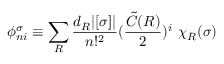Convert formula to latex. <formula><loc_0><loc_0><loc_500><loc_500>\phi _ { n i } ^ { \sigma } \equiv \sum _ { R } \frac { d _ { R } | [ \sigma ] | } { n ! ^ { 2 } } ( \frac { { \tilde { C } } ( R ) } { 2 } ) ^ { i } \ \chi _ { R } ( \sigma )</formula> 